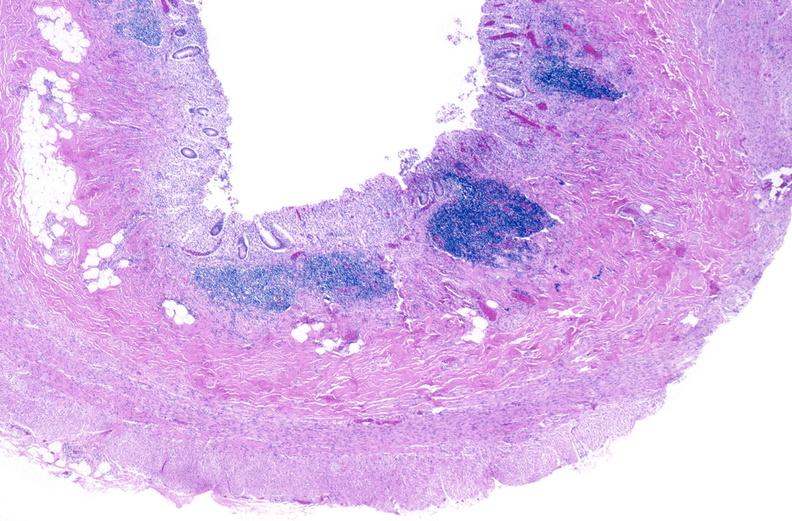does autopsy show normal appendix?
Answer the question using a single word or phrase. No 